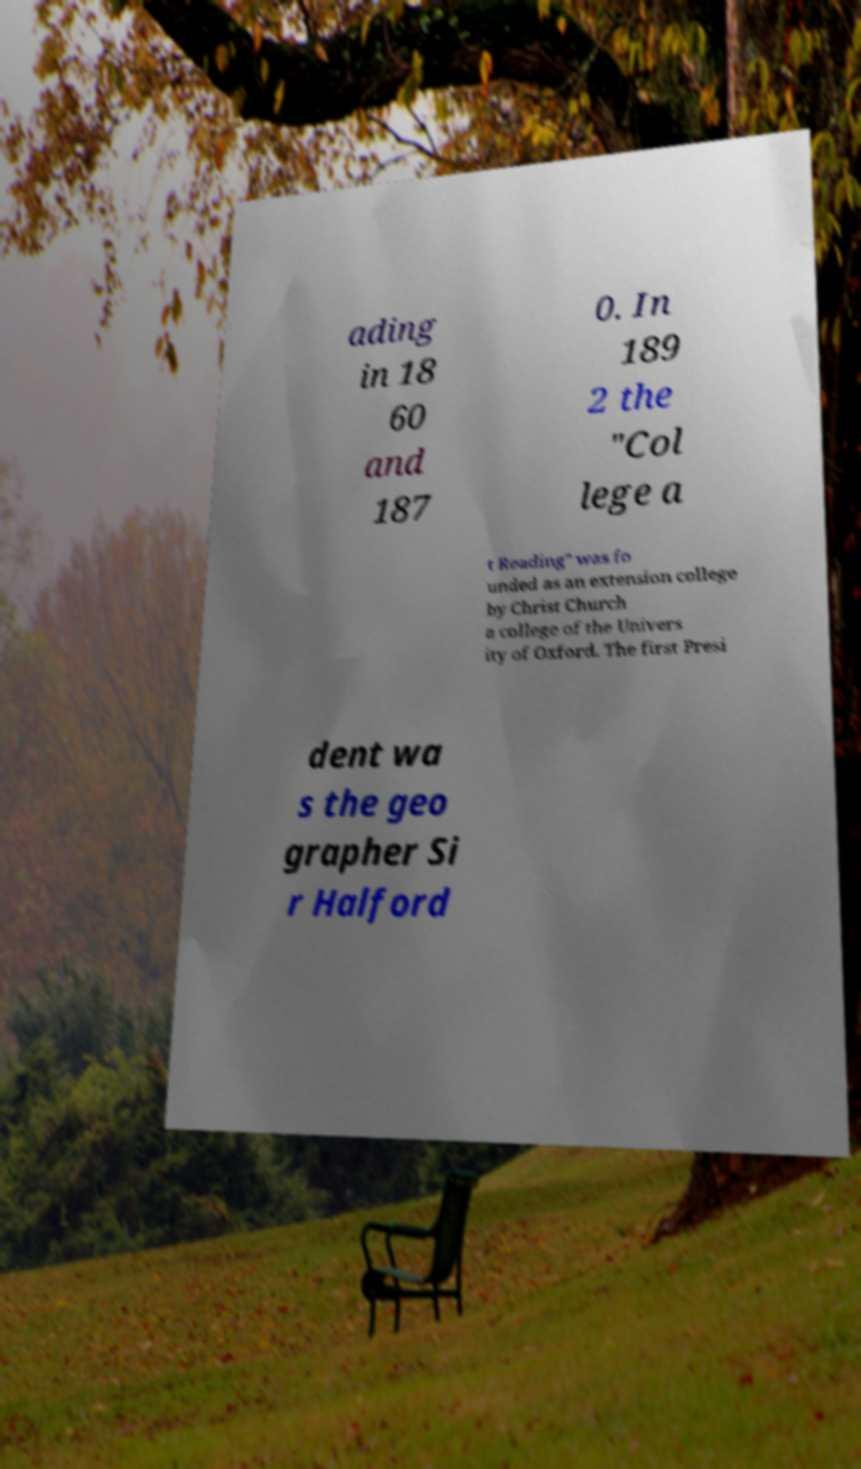I need the written content from this picture converted into text. Can you do that? ading in 18 60 and 187 0. In 189 2 the "Col lege a t Reading" was fo unded as an extension college by Christ Church a college of the Univers ity of Oxford. The first Presi dent wa s the geo grapher Si r Halford 